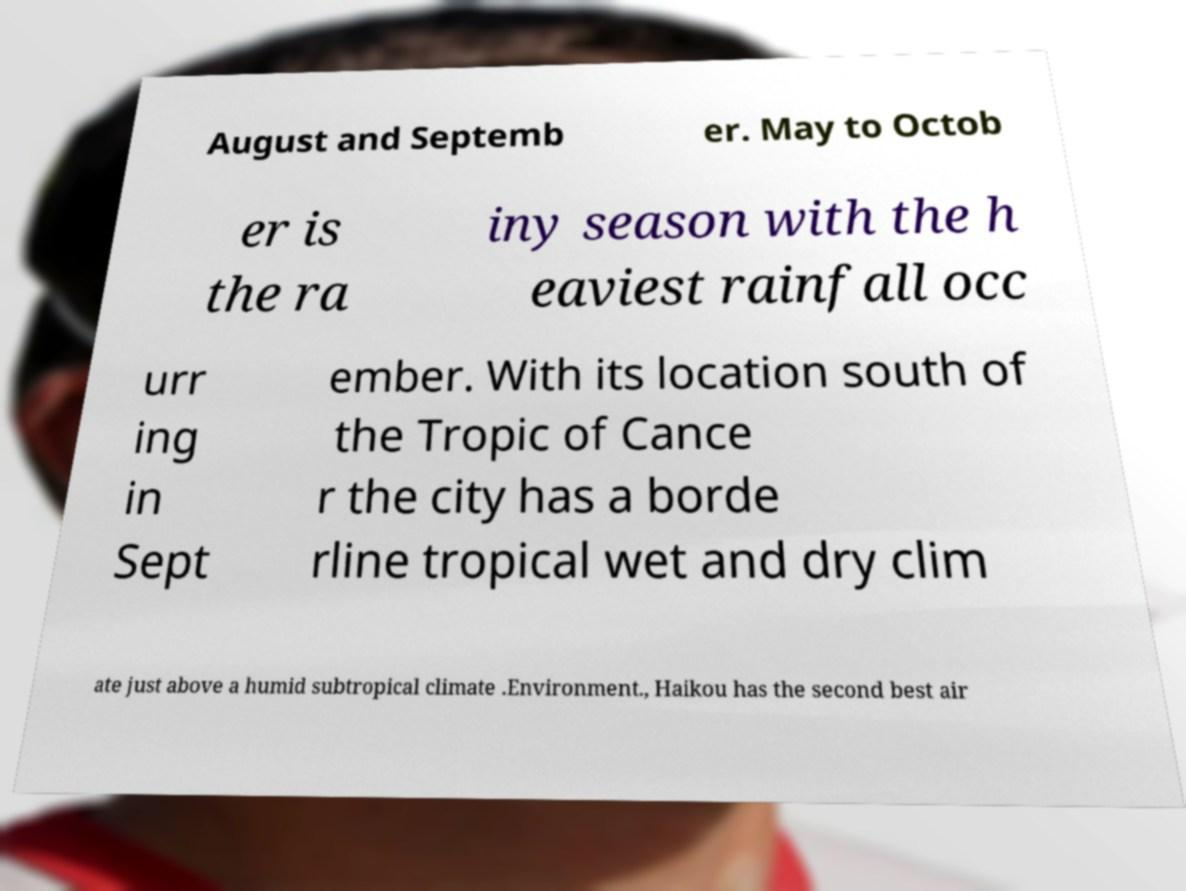For documentation purposes, I need the text within this image transcribed. Could you provide that? August and Septemb er. May to Octob er is the ra iny season with the h eaviest rainfall occ urr ing in Sept ember. With its location south of the Tropic of Cance r the city has a borde rline tropical wet and dry clim ate just above a humid subtropical climate .Environment., Haikou has the second best air 